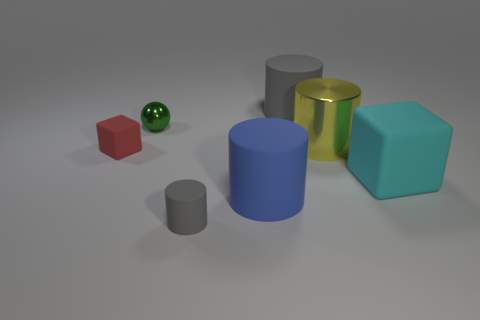Are there any big cylinders of the same color as the tiny cylinder?
Your response must be concise. Yes. There is a metal thing to the left of the gray thing right of the gray matte object left of the large gray cylinder; what shape is it?
Ensure brevity in your answer.  Sphere. There is a red rubber object that is in front of the yellow object; is its size the same as the big yellow metallic object?
Your answer should be compact. No. What is the shape of the rubber thing that is both behind the cyan matte thing and right of the small gray cylinder?
Make the answer very short. Cylinder. Do the tiny cylinder and the large matte cylinder that is on the right side of the blue cylinder have the same color?
Provide a short and direct response. Yes. There is a rubber block that is in front of the rubber thing on the left side of the tiny object in front of the small matte cube; what is its color?
Keep it short and to the point. Cyan. The other big matte object that is the same shape as the red thing is what color?
Make the answer very short. Cyan. Are there an equal number of cylinders that are to the left of the large yellow shiny object and small green metallic cylinders?
Give a very brief answer. No. What number of cylinders are either metal things or big things?
Ensure brevity in your answer.  3. There is a small block that is made of the same material as the big blue cylinder; what color is it?
Provide a succinct answer. Red. 